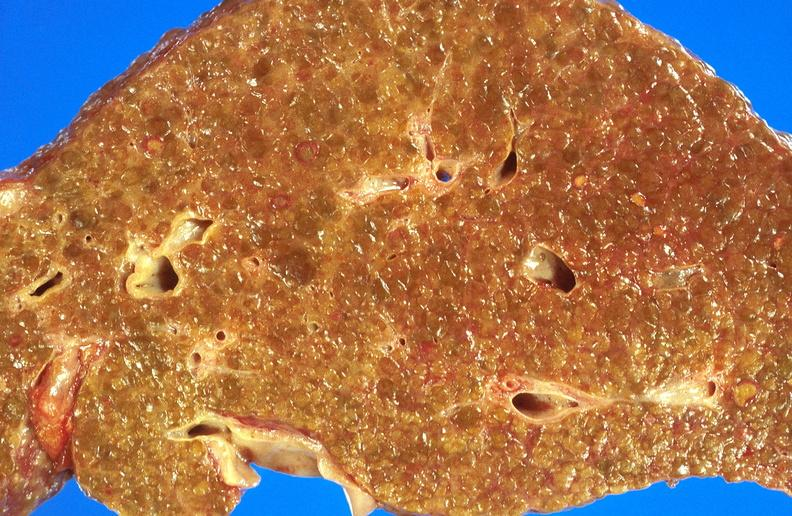s glioma present?
Answer the question using a single word or phrase. No 